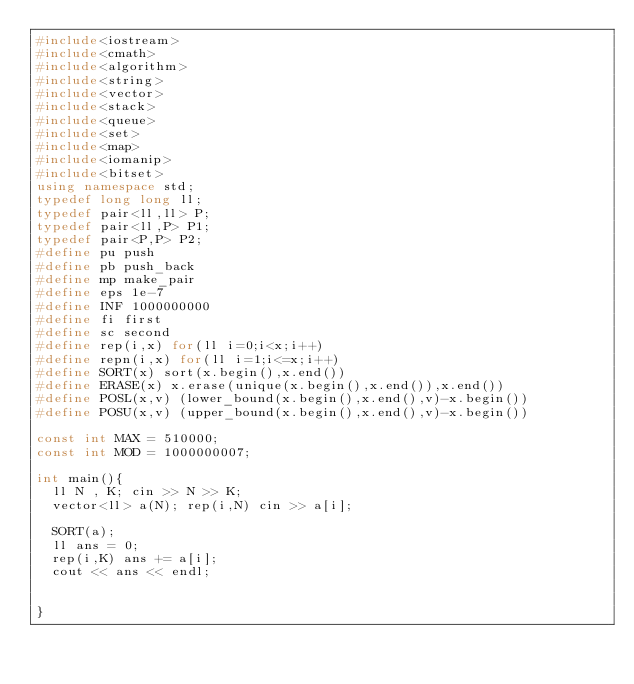Convert code to text. <code><loc_0><loc_0><loc_500><loc_500><_C++_>#include<iostream>
#include<cmath>
#include<algorithm>
#include<string>
#include<vector>
#include<stack>
#include<queue>
#include<set>
#include<map>
#include<iomanip>
#include<bitset>
using namespace std;
typedef long long ll;
typedef pair<ll,ll> P;
typedef pair<ll,P> P1;
typedef pair<P,P> P2;
#define pu push
#define pb push_back
#define mp make_pair
#define eps 1e-7
#define INF 1000000000
#define fi first
#define sc second
#define rep(i,x) for(ll i=0;i<x;i++)
#define repn(i,x) for(ll i=1;i<=x;i++)
#define SORT(x) sort(x.begin(),x.end())
#define ERASE(x) x.erase(unique(x.begin(),x.end()),x.end())
#define POSL(x,v) (lower_bound(x.begin(),x.end(),v)-x.begin())
#define POSU(x,v) (upper_bound(x.begin(),x.end(),v)-x.begin())

const int MAX = 510000;
const int MOD = 1000000007;

int main(){
  ll N , K; cin >> N >> K;
  vector<ll> a(N); rep(i,N) cin >> a[i];

  SORT(a);
  ll ans = 0;
  rep(i,K) ans += a[i];
  cout << ans << endl;


}
</code> 